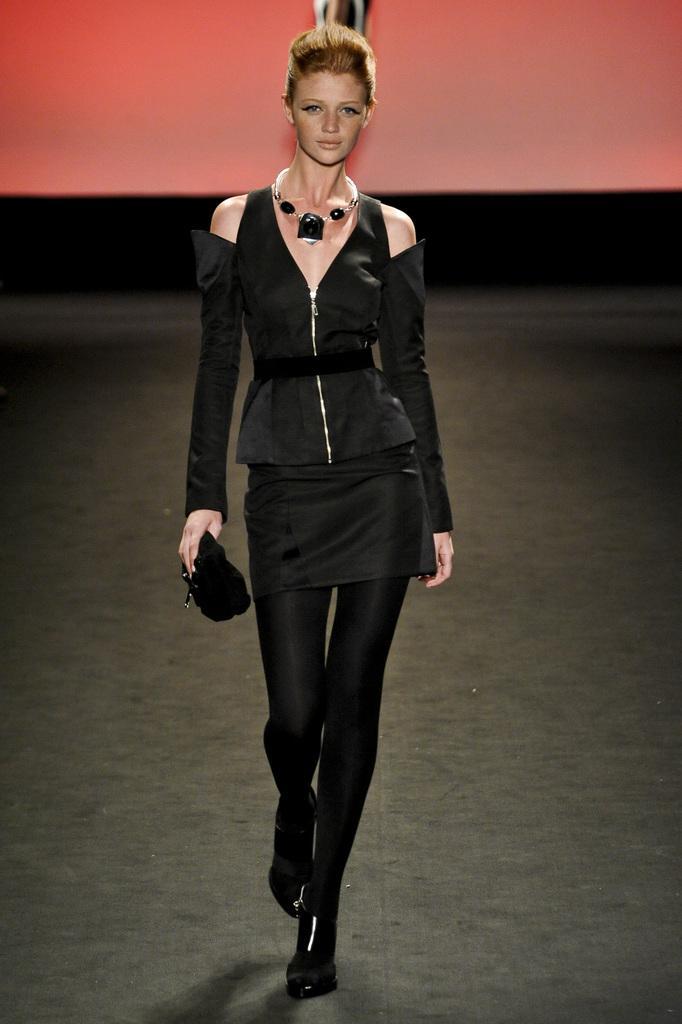Could you give a brief overview of what you see in this image? This image is taken indoors. In the background there is a wall. At the bottom of the image there is a floor. In the middle of the image a woman is walking on the floor and she is holding a purse in her hand. 